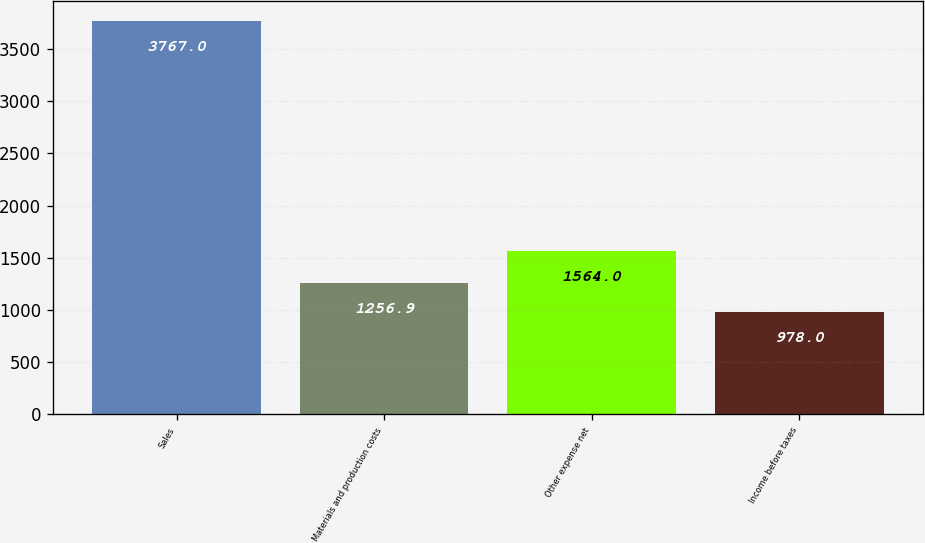Convert chart to OTSL. <chart><loc_0><loc_0><loc_500><loc_500><bar_chart><fcel>Sales<fcel>Materials and production costs<fcel>Other expense net<fcel>Income before taxes<nl><fcel>3767<fcel>1256.9<fcel>1564<fcel>978<nl></chart> 